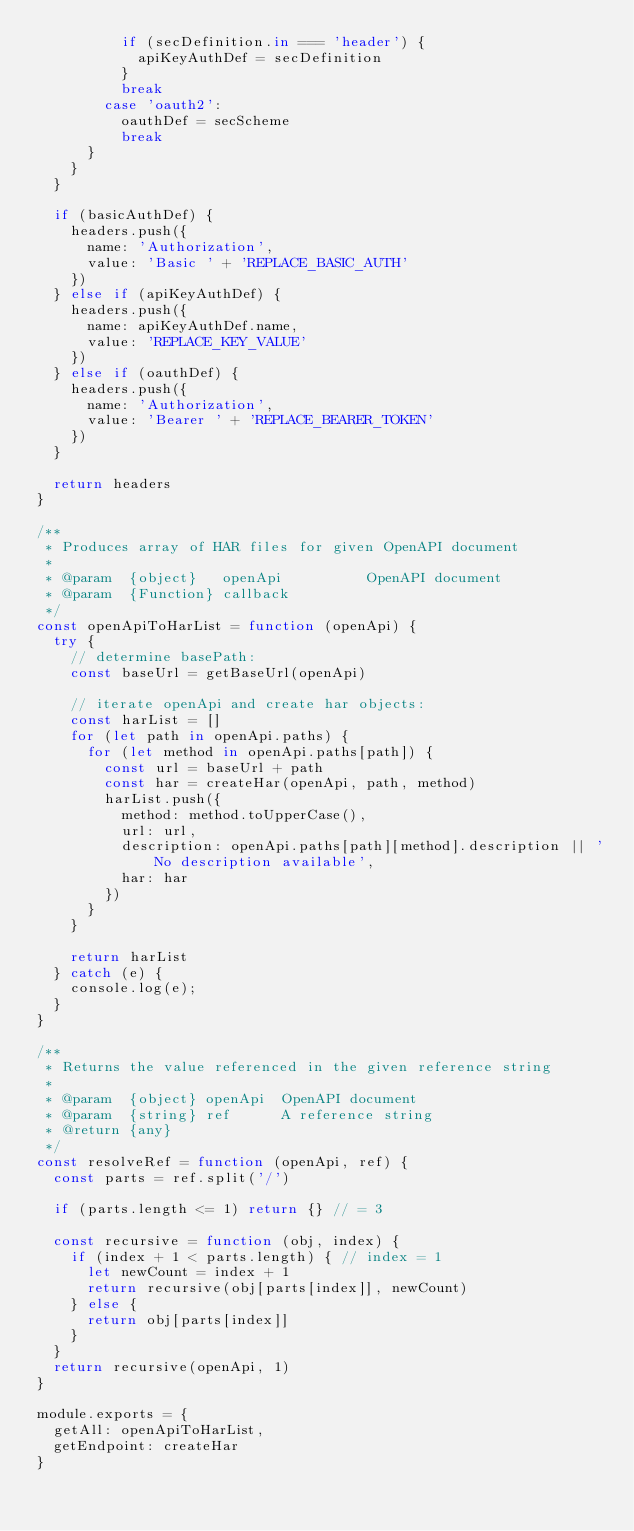<code> <loc_0><loc_0><loc_500><loc_500><_JavaScript_>          if (secDefinition.in === 'header') {
            apiKeyAuthDef = secDefinition
          }
          break
        case 'oauth2':
          oauthDef = secScheme
          break
      }
    }
  }

  if (basicAuthDef) {
    headers.push({
      name: 'Authorization',
      value: 'Basic ' + 'REPLACE_BASIC_AUTH'
    })
  } else if (apiKeyAuthDef) {
    headers.push({
      name: apiKeyAuthDef.name,
      value: 'REPLACE_KEY_VALUE'
    })
  } else if (oauthDef) {
    headers.push({
      name: 'Authorization',
      value: 'Bearer ' + 'REPLACE_BEARER_TOKEN'
    })
  }

  return headers
}

/**
 * Produces array of HAR files for given OpenAPI document
 *
 * @param  {object}   openApi          OpenAPI document
 * @param  {Function} callback
 */
const openApiToHarList = function (openApi) {
  try {
    // determine basePath:
    const baseUrl = getBaseUrl(openApi)

    // iterate openApi and create har objects:
    const harList = []
    for (let path in openApi.paths) {
      for (let method in openApi.paths[path]) {
        const url = baseUrl + path
        const har = createHar(openApi, path, method)
        harList.push({
          method: method.toUpperCase(),
          url: url,
          description: openApi.paths[path][method].description || 'No description available',
          har: har
        })
      }
    }

    return harList
  } catch (e) {
    console.log(e);
  }
}

/**
 * Returns the value referenced in the given reference string
 *
 * @param  {object} openApi  OpenAPI document
 * @param  {string} ref      A reference string
 * @return {any}
 */
const resolveRef = function (openApi, ref) {
  const parts = ref.split('/')

  if (parts.length <= 1) return {} // = 3

  const recursive = function (obj, index) {
    if (index + 1 < parts.length) { // index = 1
      let newCount = index + 1
      return recursive(obj[parts[index]], newCount)
    } else {
      return obj[parts[index]]
    }
  }
  return recursive(openApi, 1)
}

module.exports = {
  getAll: openApiToHarList,
  getEndpoint: createHar
}
</code> 